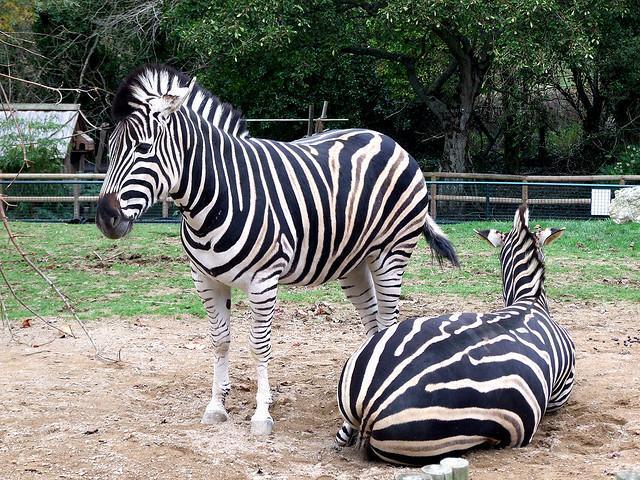How many zebras are in this photo?
Give a very brief answer. 2. How many zebras are there?
Give a very brief answer. 2. 